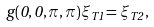<formula> <loc_0><loc_0><loc_500><loc_500>g ( 0 , 0 , \pi , \pi ) \xi _ { T 1 } = \xi _ { T 2 } \, ,</formula> 